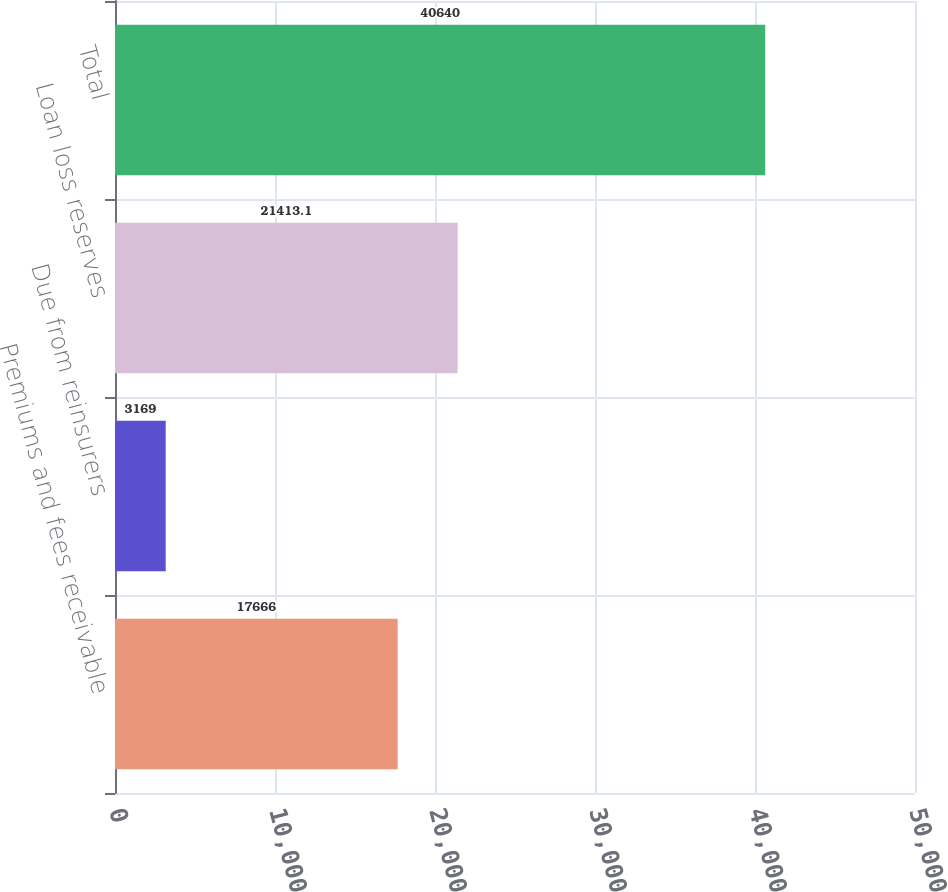Convert chart. <chart><loc_0><loc_0><loc_500><loc_500><bar_chart><fcel>Premiums and fees receivable<fcel>Due from reinsurers<fcel>Loan loss reserves<fcel>Total<nl><fcel>17666<fcel>3169<fcel>21413.1<fcel>40640<nl></chart> 